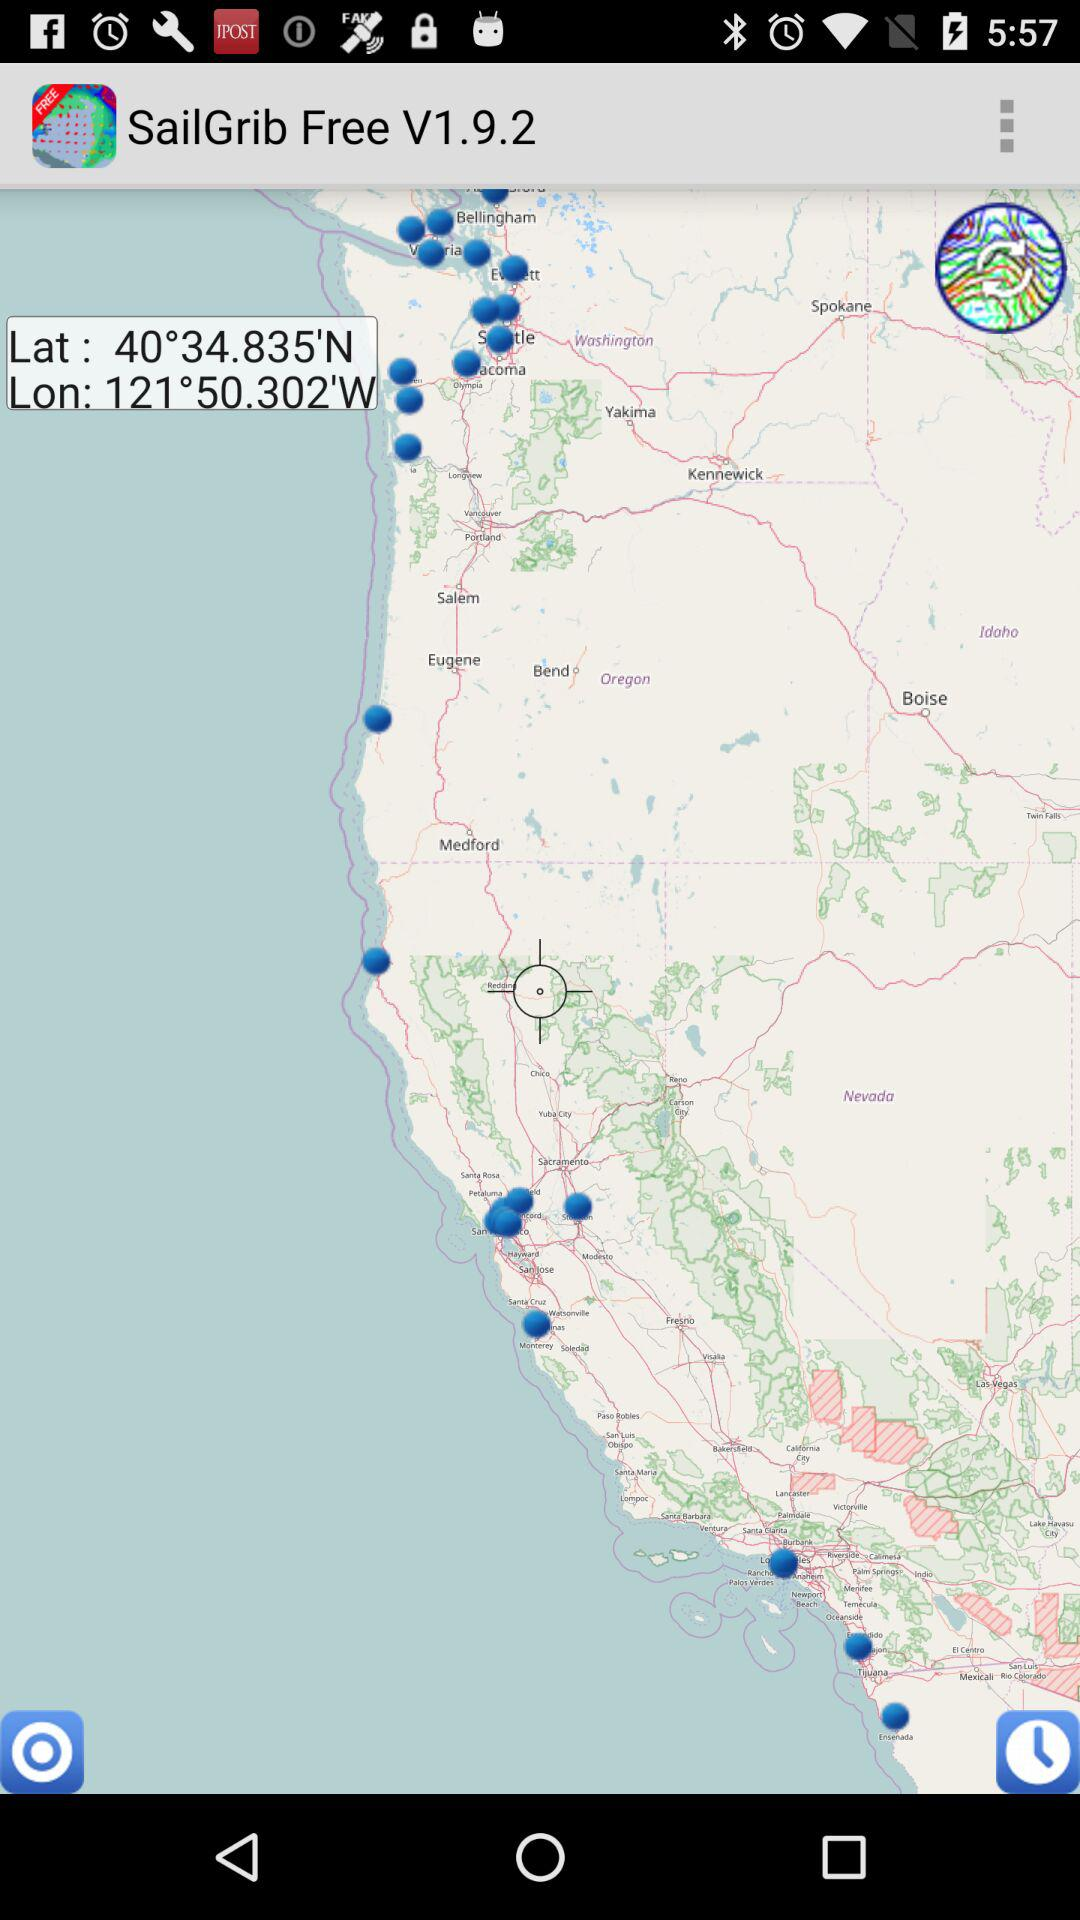What are the latitudes and longitudes? The latitude is 40°34.835'N and the longitude is 121°50.302'W. 